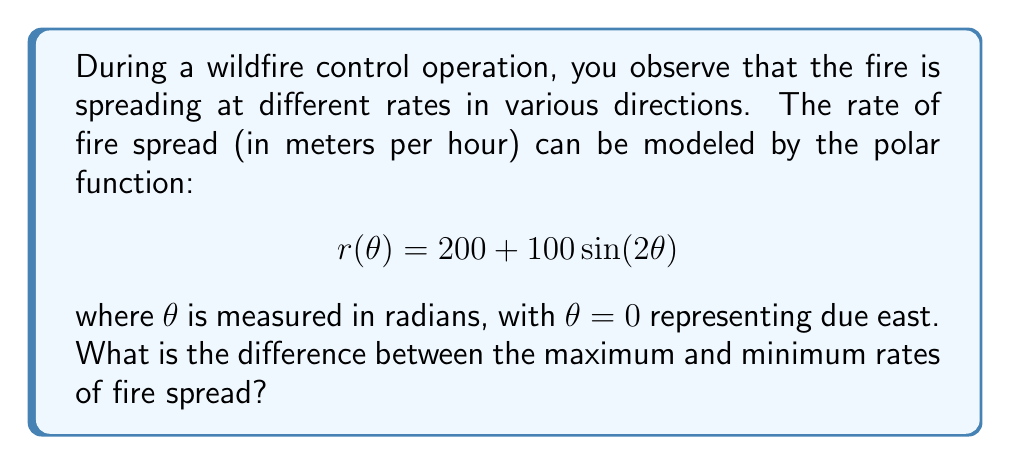What is the answer to this math problem? To solve this problem, we need to follow these steps:

1) First, we need to find the maximum and minimum values of the function $r(\theta) = 200 + 100\sin(2\theta)$.

2) The amplitude of the sine function is 100, and it's centered at 200. This means the function will oscillate between:
   
   Maximum: $200 + 100 = 300$
   Minimum: $200 - 100 = 100$

3) We can verify these values:
   
   Maximum occurs when $\sin(2\theta) = 1$, which happens when $2\theta = \frac{\pi}{2}, \frac{5\pi}{2}, etc.$
   Minimum occurs when $\sin(2\theta) = -1$, which happens when $2\theta = \frac{3\pi}{2}, \frac{7\pi}{2}, etc.$

4) The maximum rate of fire spread is 300 meters per hour.
   The minimum rate of fire spread is 100 meters per hour.

5) The difference between the maximum and minimum rates is:

   $300 - 100 = 200$ meters per hour

This difference represents the range of fire spread rates in different directions.
Answer: The difference between the maximum and minimum rates of fire spread is 200 meters per hour. 